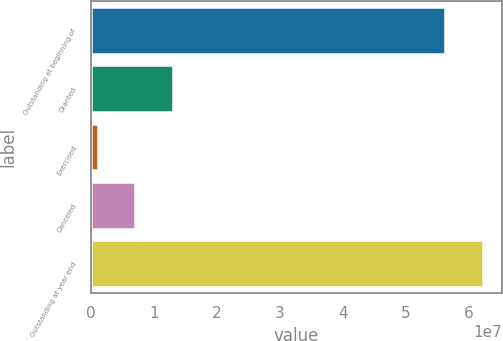Convert chart to OTSL. <chart><loc_0><loc_0><loc_500><loc_500><bar_chart><fcel>Outstanding at beginning of<fcel>Granted<fcel>Exercised<fcel>Canceled<fcel>Outstanding at year end<nl><fcel>5.62757e+07<fcel>1.3066e+07<fcel>1.14946e+06<fcel>7.10775e+06<fcel>6.2234e+07<nl></chart> 